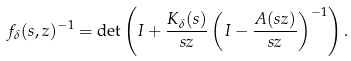Convert formula to latex. <formula><loc_0><loc_0><loc_500><loc_500>f _ { \delta } ( s , z ) ^ { - 1 } = \det \left ( I + \frac { K _ { \delta } ( s ) } { s z } \left ( I - \frac { A ( s z ) } { s z } \right ) ^ { - 1 } \right ) .</formula> 